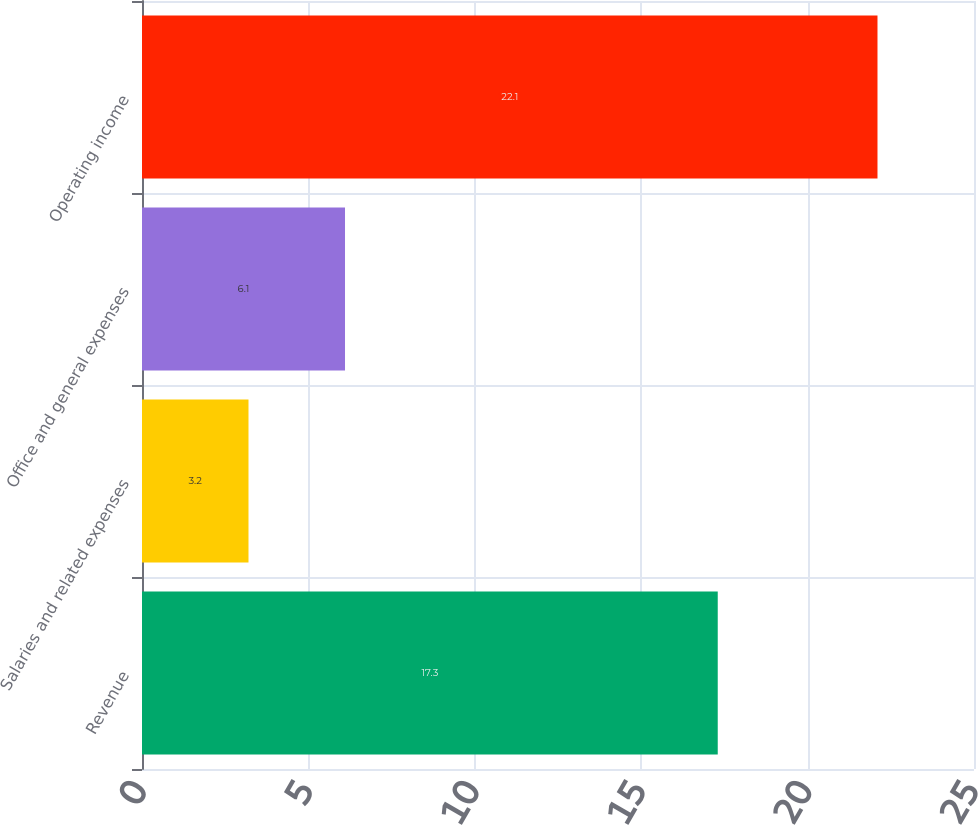Convert chart. <chart><loc_0><loc_0><loc_500><loc_500><bar_chart><fcel>Revenue<fcel>Salaries and related expenses<fcel>Office and general expenses<fcel>Operating income<nl><fcel>17.3<fcel>3.2<fcel>6.1<fcel>22.1<nl></chart> 